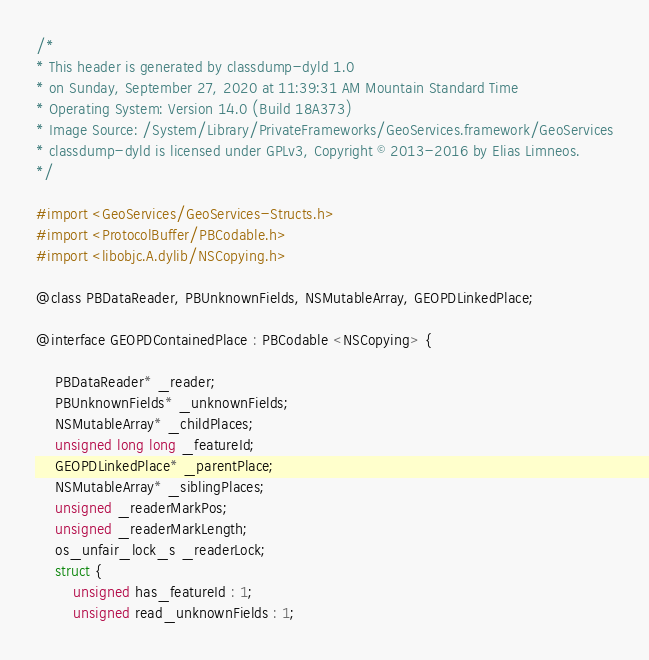Convert code to text. <code><loc_0><loc_0><loc_500><loc_500><_C_>/*
* This header is generated by classdump-dyld 1.0
* on Sunday, September 27, 2020 at 11:39:31 AM Mountain Standard Time
* Operating System: Version 14.0 (Build 18A373)
* Image Source: /System/Library/PrivateFrameworks/GeoServices.framework/GeoServices
* classdump-dyld is licensed under GPLv3, Copyright © 2013-2016 by Elias Limneos.
*/

#import <GeoServices/GeoServices-Structs.h>
#import <ProtocolBuffer/PBCodable.h>
#import <libobjc.A.dylib/NSCopying.h>

@class PBDataReader, PBUnknownFields, NSMutableArray, GEOPDLinkedPlace;

@interface GEOPDContainedPlace : PBCodable <NSCopying> {

	PBDataReader* _reader;
	PBUnknownFields* _unknownFields;
	NSMutableArray* _childPlaces;
	unsigned long long _featureId;
	GEOPDLinkedPlace* _parentPlace;
	NSMutableArray* _siblingPlaces;
	unsigned _readerMarkPos;
	unsigned _readerMarkLength;
	os_unfair_lock_s _readerLock;
	struct {
		unsigned has_featureId : 1;
		unsigned read_unknownFields : 1;</code> 